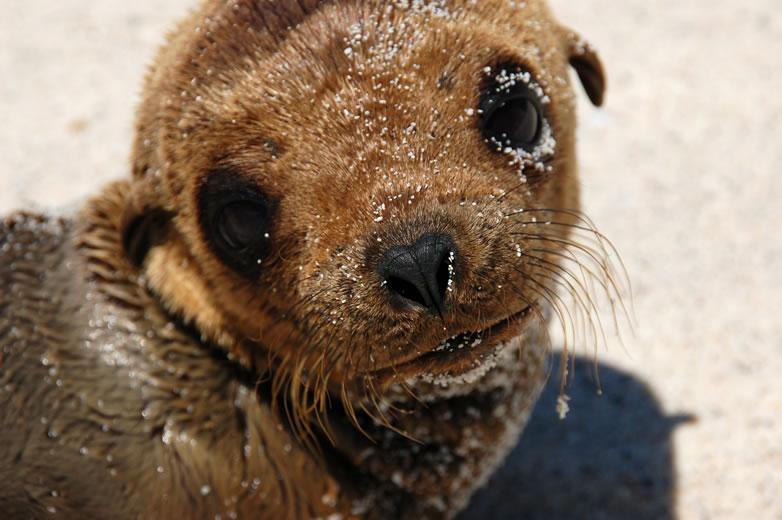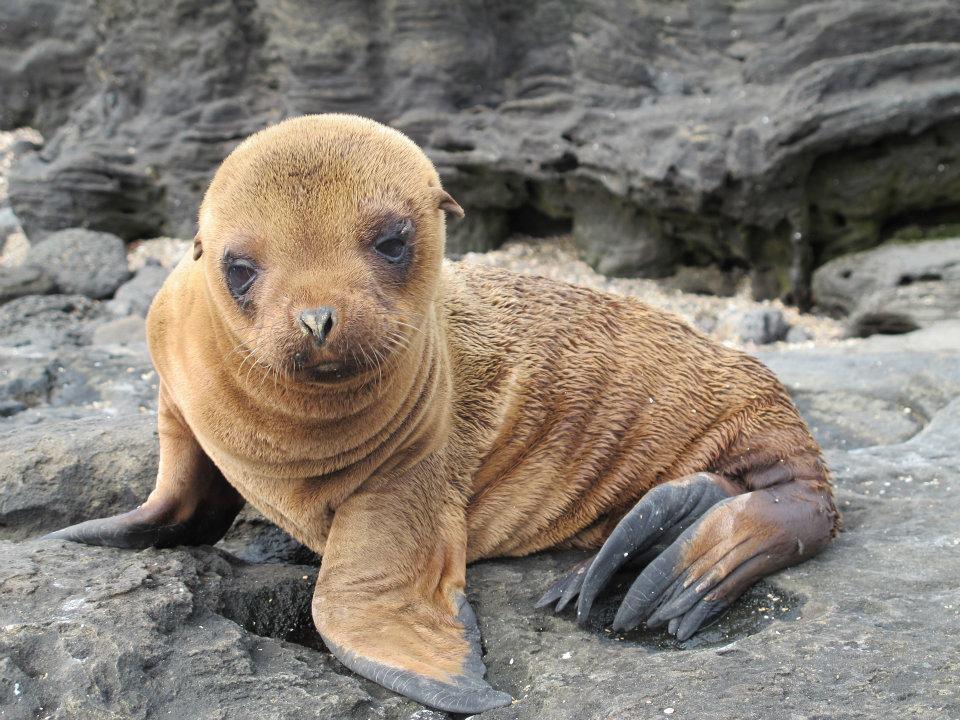The first image is the image on the left, the second image is the image on the right. Evaluate the accuracy of this statement regarding the images: "In one image there is a lone seal pup looking towards the left of the image.". Is it true? Answer yes or no. No. The first image is the image on the left, the second image is the image on the right. Assess this claim about the two images: "A lone seal sits and looks to the left of the image.". Correct or not? Answer yes or no. No. 